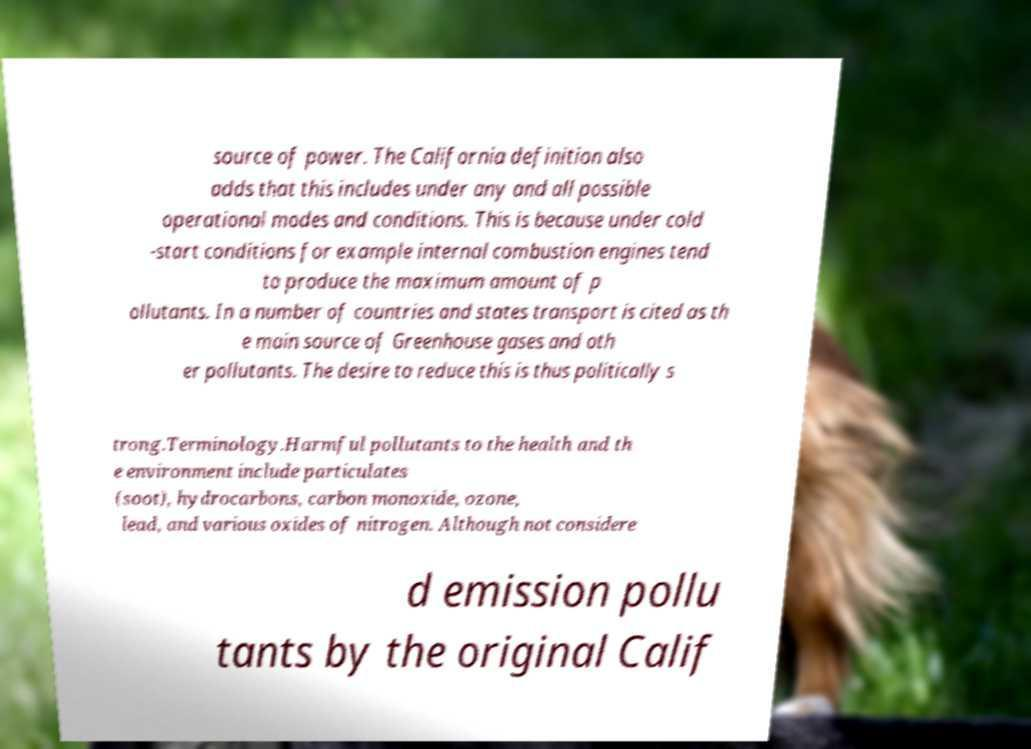There's text embedded in this image that I need extracted. Can you transcribe it verbatim? source of power. The California definition also adds that this includes under any and all possible operational modes and conditions. This is because under cold -start conditions for example internal combustion engines tend to produce the maximum amount of p ollutants. In a number of countries and states transport is cited as th e main source of Greenhouse gases and oth er pollutants. The desire to reduce this is thus politically s trong.Terminology.Harmful pollutants to the health and th e environment include particulates (soot), hydrocarbons, carbon monoxide, ozone, lead, and various oxides of nitrogen. Although not considere d emission pollu tants by the original Calif 